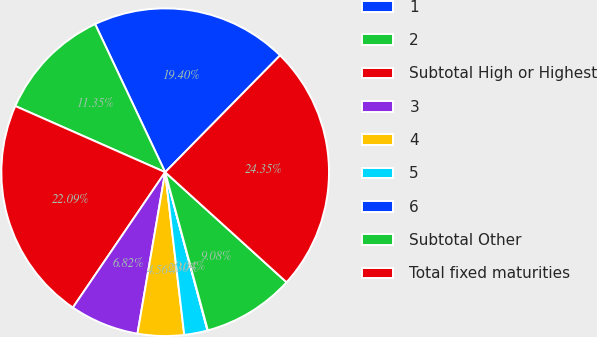<chart> <loc_0><loc_0><loc_500><loc_500><pie_chart><fcel>1<fcel>2<fcel>Subtotal High or Highest<fcel>3<fcel>4<fcel>5<fcel>6<fcel>Subtotal Other<fcel>Total fixed maturities<nl><fcel>19.4%<fcel>11.35%<fcel>22.09%<fcel>6.82%<fcel>4.56%<fcel>2.3%<fcel>0.04%<fcel>9.08%<fcel>24.35%<nl></chart> 